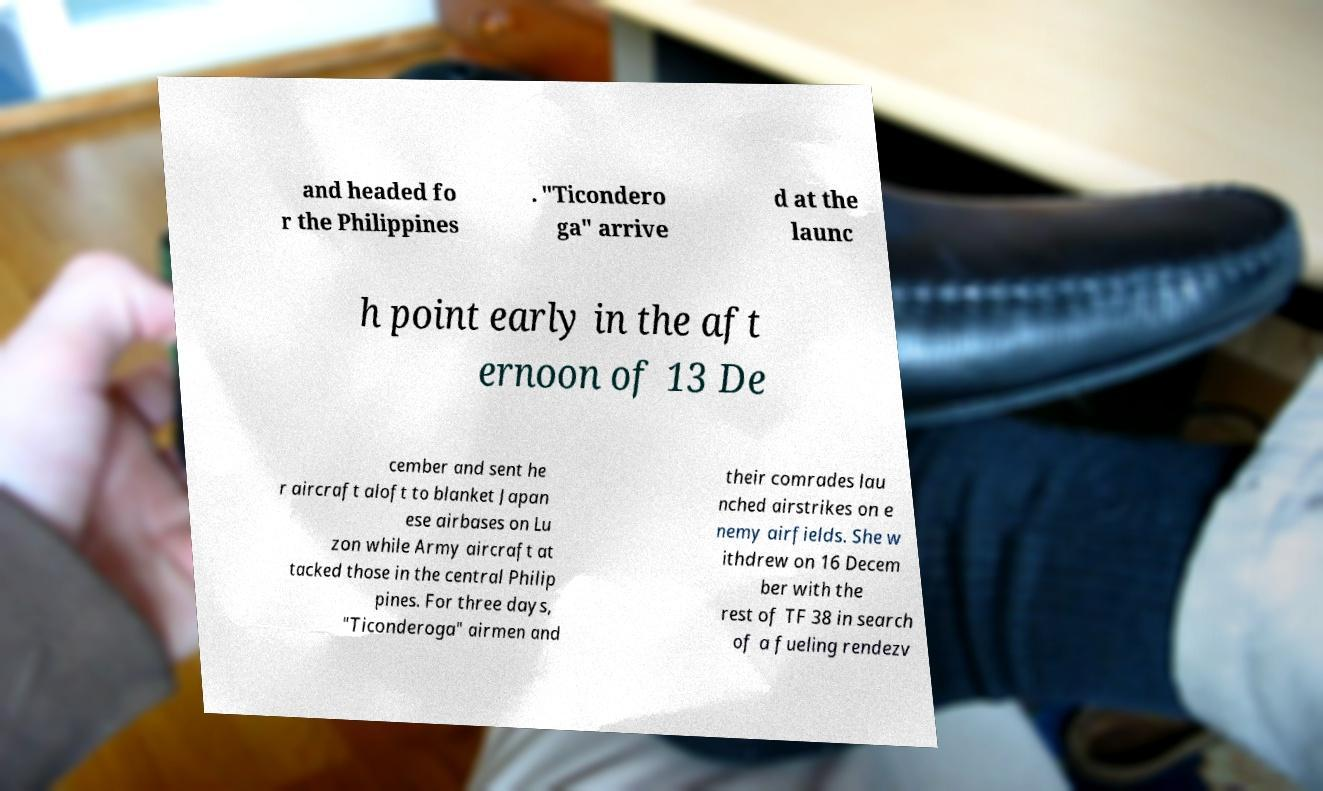Could you extract and type out the text from this image? and headed fo r the Philippines . "Ticondero ga" arrive d at the launc h point early in the aft ernoon of 13 De cember and sent he r aircraft aloft to blanket Japan ese airbases on Lu zon while Army aircraft at tacked those in the central Philip pines. For three days, "Ticonderoga" airmen and their comrades lau nched airstrikes on e nemy airfields. She w ithdrew on 16 Decem ber with the rest of TF 38 in search of a fueling rendezv 